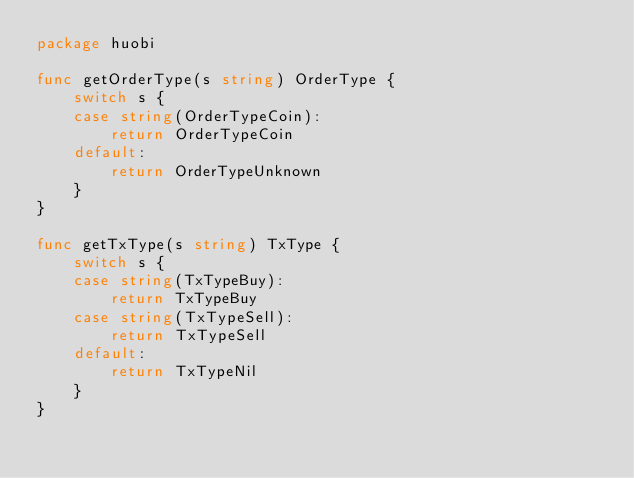<code> <loc_0><loc_0><loc_500><loc_500><_Go_>package huobi

func getOrderType(s string) OrderType {
	switch s {
	case string(OrderTypeCoin):
		return OrderTypeCoin
	default:
		return OrderTypeUnknown
	}
}

func getTxType(s string) TxType {
	switch s {
	case string(TxTypeBuy):
		return TxTypeBuy
	case string(TxTypeSell):
		return TxTypeSell
	default:
		return TxTypeNil
	}
}
</code> 